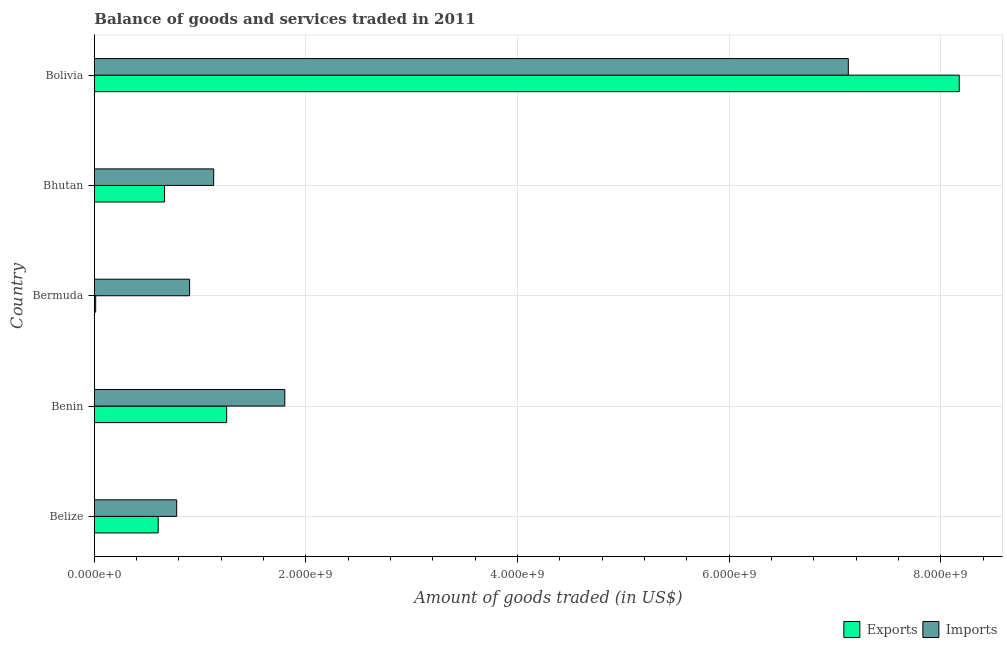How many different coloured bars are there?
Your answer should be compact. 2. How many groups of bars are there?
Keep it short and to the point. 5. How many bars are there on the 1st tick from the top?
Your answer should be compact. 2. How many bars are there on the 5th tick from the bottom?
Provide a succinct answer. 2. What is the label of the 3rd group of bars from the top?
Make the answer very short. Bermuda. In how many cases, is the number of bars for a given country not equal to the number of legend labels?
Provide a short and direct response. 0. What is the amount of goods imported in Bermuda?
Keep it short and to the point. 9.00e+08. Across all countries, what is the maximum amount of goods exported?
Give a very brief answer. 8.17e+09. Across all countries, what is the minimum amount of goods imported?
Give a very brief answer. 7.78e+08. In which country was the amount of goods exported minimum?
Your answer should be very brief. Bermuda. What is the total amount of goods exported in the graph?
Your answer should be very brief. 1.07e+1. What is the difference between the amount of goods imported in Belize and that in Bhutan?
Provide a short and direct response. -3.50e+08. What is the difference between the amount of goods exported in Bermuda and the amount of goods imported in Belize?
Your answer should be very brief. -7.66e+08. What is the average amount of goods exported per country?
Offer a terse response. 2.14e+09. What is the difference between the amount of goods exported and amount of goods imported in Bermuda?
Provide a succinct answer. -8.88e+08. What is the ratio of the amount of goods imported in Benin to that in Bhutan?
Offer a very short reply. 1.6. What is the difference between the highest and the second highest amount of goods exported?
Your answer should be compact. 6.92e+09. What is the difference between the highest and the lowest amount of goods exported?
Your answer should be compact. 8.16e+09. What does the 1st bar from the top in Belize represents?
Provide a short and direct response. Imports. What does the 2nd bar from the bottom in Belize represents?
Keep it short and to the point. Imports. How many countries are there in the graph?
Your answer should be compact. 5. What is the difference between two consecutive major ticks on the X-axis?
Your answer should be very brief. 2.00e+09. Are the values on the major ticks of X-axis written in scientific E-notation?
Ensure brevity in your answer.  Yes. Does the graph contain any zero values?
Your answer should be very brief. No. Does the graph contain grids?
Provide a succinct answer. Yes. Where does the legend appear in the graph?
Give a very brief answer. Bottom right. How many legend labels are there?
Ensure brevity in your answer.  2. How are the legend labels stacked?
Your answer should be very brief. Horizontal. What is the title of the graph?
Ensure brevity in your answer.  Balance of goods and services traded in 2011. Does "National Tourists" appear as one of the legend labels in the graph?
Keep it short and to the point. No. What is the label or title of the X-axis?
Offer a very short reply. Amount of goods traded (in US$). What is the label or title of the Y-axis?
Your response must be concise. Country. What is the Amount of goods traded (in US$) in Exports in Belize?
Your answer should be very brief. 6.04e+08. What is the Amount of goods traded (in US$) of Imports in Belize?
Your answer should be compact. 7.78e+08. What is the Amount of goods traded (in US$) in Exports in Benin?
Your answer should be compact. 1.25e+09. What is the Amount of goods traded (in US$) of Imports in Benin?
Provide a succinct answer. 1.80e+09. What is the Amount of goods traded (in US$) in Exports in Bermuda?
Provide a short and direct response. 1.26e+07. What is the Amount of goods traded (in US$) in Imports in Bermuda?
Make the answer very short. 9.00e+08. What is the Amount of goods traded (in US$) of Exports in Bhutan?
Your answer should be compact. 6.64e+08. What is the Amount of goods traded (in US$) of Imports in Bhutan?
Provide a succinct answer. 1.13e+09. What is the Amount of goods traded (in US$) of Exports in Bolivia?
Keep it short and to the point. 8.17e+09. What is the Amount of goods traded (in US$) in Imports in Bolivia?
Provide a short and direct response. 7.13e+09. Across all countries, what is the maximum Amount of goods traded (in US$) of Exports?
Keep it short and to the point. 8.17e+09. Across all countries, what is the maximum Amount of goods traded (in US$) of Imports?
Ensure brevity in your answer.  7.13e+09. Across all countries, what is the minimum Amount of goods traded (in US$) in Exports?
Your answer should be compact. 1.26e+07. Across all countries, what is the minimum Amount of goods traded (in US$) of Imports?
Keep it short and to the point. 7.78e+08. What is the total Amount of goods traded (in US$) in Exports in the graph?
Your response must be concise. 1.07e+1. What is the total Amount of goods traded (in US$) of Imports in the graph?
Offer a very short reply. 1.17e+1. What is the difference between the Amount of goods traded (in US$) of Exports in Belize and that in Benin?
Ensure brevity in your answer.  -6.47e+08. What is the difference between the Amount of goods traded (in US$) of Imports in Belize and that in Benin?
Make the answer very short. -1.02e+09. What is the difference between the Amount of goods traded (in US$) of Exports in Belize and that in Bermuda?
Your answer should be very brief. 5.91e+08. What is the difference between the Amount of goods traded (in US$) of Imports in Belize and that in Bermuda?
Provide a short and direct response. -1.22e+08. What is the difference between the Amount of goods traded (in US$) of Exports in Belize and that in Bhutan?
Give a very brief answer. -6.01e+07. What is the difference between the Amount of goods traded (in US$) in Imports in Belize and that in Bhutan?
Provide a short and direct response. -3.50e+08. What is the difference between the Amount of goods traded (in US$) in Exports in Belize and that in Bolivia?
Provide a succinct answer. -7.57e+09. What is the difference between the Amount of goods traded (in US$) of Imports in Belize and that in Bolivia?
Keep it short and to the point. -6.35e+09. What is the difference between the Amount of goods traded (in US$) in Exports in Benin and that in Bermuda?
Your answer should be compact. 1.24e+09. What is the difference between the Amount of goods traded (in US$) of Imports in Benin and that in Bermuda?
Keep it short and to the point. 9.00e+08. What is the difference between the Amount of goods traded (in US$) in Exports in Benin and that in Bhutan?
Offer a very short reply. 5.87e+08. What is the difference between the Amount of goods traded (in US$) of Imports in Benin and that in Bhutan?
Ensure brevity in your answer.  6.72e+08. What is the difference between the Amount of goods traded (in US$) of Exports in Benin and that in Bolivia?
Give a very brief answer. -6.92e+09. What is the difference between the Amount of goods traded (in US$) of Imports in Benin and that in Bolivia?
Make the answer very short. -5.33e+09. What is the difference between the Amount of goods traded (in US$) in Exports in Bermuda and that in Bhutan?
Make the answer very short. -6.51e+08. What is the difference between the Amount of goods traded (in US$) of Imports in Bermuda and that in Bhutan?
Give a very brief answer. -2.28e+08. What is the difference between the Amount of goods traded (in US$) in Exports in Bermuda and that in Bolivia?
Keep it short and to the point. -8.16e+09. What is the difference between the Amount of goods traded (in US$) of Imports in Bermuda and that in Bolivia?
Your answer should be very brief. -6.23e+09. What is the difference between the Amount of goods traded (in US$) in Exports in Bhutan and that in Bolivia?
Your answer should be compact. -7.51e+09. What is the difference between the Amount of goods traded (in US$) of Imports in Bhutan and that in Bolivia?
Your answer should be very brief. -6.00e+09. What is the difference between the Amount of goods traded (in US$) in Exports in Belize and the Amount of goods traded (in US$) in Imports in Benin?
Your answer should be compact. -1.20e+09. What is the difference between the Amount of goods traded (in US$) of Exports in Belize and the Amount of goods traded (in US$) of Imports in Bermuda?
Provide a succinct answer. -2.97e+08. What is the difference between the Amount of goods traded (in US$) in Exports in Belize and the Amount of goods traded (in US$) in Imports in Bhutan?
Make the answer very short. -5.24e+08. What is the difference between the Amount of goods traded (in US$) in Exports in Belize and the Amount of goods traded (in US$) in Imports in Bolivia?
Your response must be concise. -6.52e+09. What is the difference between the Amount of goods traded (in US$) in Exports in Benin and the Amount of goods traded (in US$) in Imports in Bermuda?
Provide a short and direct response. 3.50e+08. What is the difference between the Amount of goods traded (in US$) in Exports in Benin and the Amount of goods traded (in US$) in Imports in Bhutan?
Offer a very short reply. 1.23e+08. What is the difference between the Amount of goods traded (in US$) of Exports in Benin and the Amount of goods traded (in US$) of Imports in Bolivia?
Offer a terse response. -5.88e+09. What is the difference between the Amount of goods traded (in US$) in Exports in Bermuda and the Amount of goods traded (in US$) in Imports in Bhutan?
Offer a very short reply. -1.12e+09. What is the difference between the Amount of goods traded (in US$) of Exports in Bermuda and the Amount of goods traded (in US$) of Imports in Bolivia?
Provide a succinct answer. -7.11e+09. What is the difference between the Amount of goods traded (in US$) in Exports in Bhutan and the Amount of goods traded (in US$) in Imports in Bolivia?
Offer a terse response. -6.46e+09. What is the average Amount of goods traded (in US$) of Exports per country?
Keep it short and to the point. 2.14e+09. What is the average Amount of goods traded (in US$) in Imports per country?
Keep it short and to the point. 2.35e+09. What is the difference between the Amount of goods traded (in US$) of Exports and Amount of goods traded (in US$) of Imports in Belize?
Offer a terse response. -1.75e+08. What is the difference between the Amount of goods traded (in US$) of Exports and Amount of goods traded (in US$) of Imports in Benin?
Offer a terse response. -5.50e+08. What is the difference between the Amount of goods traded (in US$) of Exports and Amount of goods traded (in US$) of Imports in Bermuda?
Keep it short and to the point. -8.88e+08. What is the difference between the Amount of goods traded (in US$) of Exports and Amount of goods traded (in US$) of Imports in Bhutan?
Provide a short and direct response. -4.64e+08. What is the difference between the Amount of goods traded (in US$) in Exports and Amount of goods traded (in US$) in Imports in Bolivia?
Your answer should be very brief. 1.05e+09. What is the ratio of the Amount of goods traded (in US$) of Exports in Belize to that in Benin?
Offer a very short reply. 0.48. What is the ratio of the Amount of goods traded (in US$) in Imports in Belize to that in Benin?
Provide a succinct answer. 0.43. What is the ratio of the Amount of goods traded (in US$) in Exports in Belize to that in Bermuda?
Ensure brevity in your answer.  47.79. What is the ratio of the Amount of goods traded (in US$) of Imports in Belize to that in Bermuda?
Provide a short and direct response. 0.86. What is the ratio of the Amount of goods traded (in US$) in Exports in Belize to that in Bhutan?
Make the answer very short. 0.91. What is the ratio of the Amount of goods traded (in US$) in Imports in Belize to that in Bhutan?
Your answer should be compact. 0.69. What is the ratio of the Amount of goods traded (in US$) in Exports in Belize to that in Bolivia?
Give a very brief answer. 0.07. What is the ratio of the Amount of goods traded (in US$) in Imports in Belize to that in Bolivia?
Offer a terse response. 0.11. What is the ratio of the Amount of goods traded (in US$) in Exports in Benin to that in Bermuda?
Provide a short and direct response. 99.03. What is the ratio of the Amount of goods traded (in US$) in Imports in Benin to that in Bermuda?
Make the answer very short. 2. What is the ratio of the Amount of goods traded (in US$) in Exports in Benin to that in Bhutan?
Your answer should be very brief. 1.88. What is the ratio of the Amount of goods traded (in US$) of Imports in Benin to that in Bhutan?
Offer a terse response. 1.6. What is the ratio of the Amount of goods traded (in US$) of Exports in Benin to that in Bolivia?
Provide a succinct answer. 0.15. What is the ratio of the Amount of goods traded (in US$) in Imports in Benin to that in Bolivia?
Provide a short and direct response. 0.25. What is the ratio of the Amount of goods traded (in US$) of Exports in Bermuda to that in Bhutan?
Provide a short and direct response. 0.02. What is the ratio of the Amount of goods traded (in US$) in Imports in Bermuda to that in Bhutan?
Your answer should be compact. 0.8. What is the ratio of the Amount of goods traded (in US$) of Exports in Bermuda to that in Bolivia?
Your answer should be compact. 0. What is the ratio of the Amount of goods traded (in US$) of Imports in Bermuda to that in Bolivia?
Offer a terse response. 0.13. What is the ratio of the Amount of goods traded (in US$) in Exports in Bhutan to that in Bolivia?
Provide a succinct answer. 0.08. What is the ratio of the Amount of goods traded (in US$) in Imports in Bhutan to that in Bolivia?
Provide a succinct answer. 0.16. What is the difference between the highest and the second highest Amount of goods traded (in US$) in Exports?
Your answer should be compact. 6.92e+09. What is the difference between the highest and the second highest Amount of goods traded (in US$) in Imports?
Your response must be concise. 5.33e+09. What is the difference between the highest and the lowest Amount of goods traded (in US$) of Exports?
Keep it short and to the point. 8.16e+09. What is the difference between the highest and the lowest Amount of goods traded (in US$) of Imports?
Make the answer very short. 6.35e+09. 